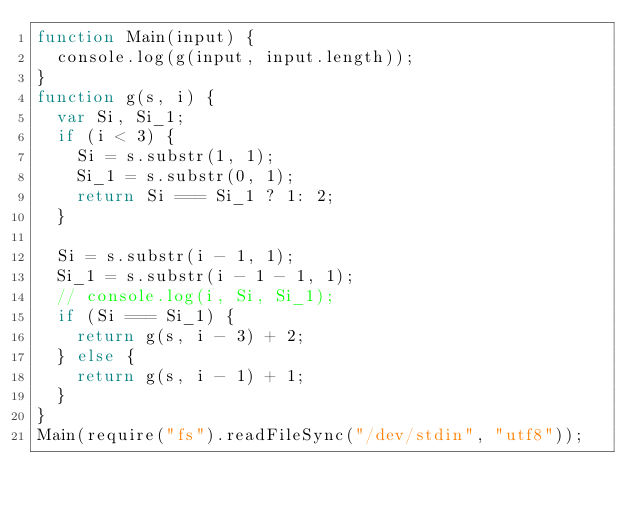Convert code to text. <code><loc_0><loc_0><loc_500><loc_500><_JavaScript_>function Main(input) {
	console.log(g(input, input.length));
}
function g(s, i) {
	var Si, Si_1;
	if (i < 3) {
		Si = s.substr(1, 1);
		Si_1 = s.substr(0, 1);
		return Si === Si_1 ? 1: 2;
	}

	Si = s.substr(i - 1, 1);
	Si_1 = s.substr(i - 1 - 1, 1);
	// console.log(i, Si, Si_1);
	if (Si === Si_1) {
		return g(s, i - 3) + 2;
	} else {
		return g(s, i - 1) + 1;
	}
}
Main(require("fs").readFileSync("/dev/stdin", "utf8"));</code> 